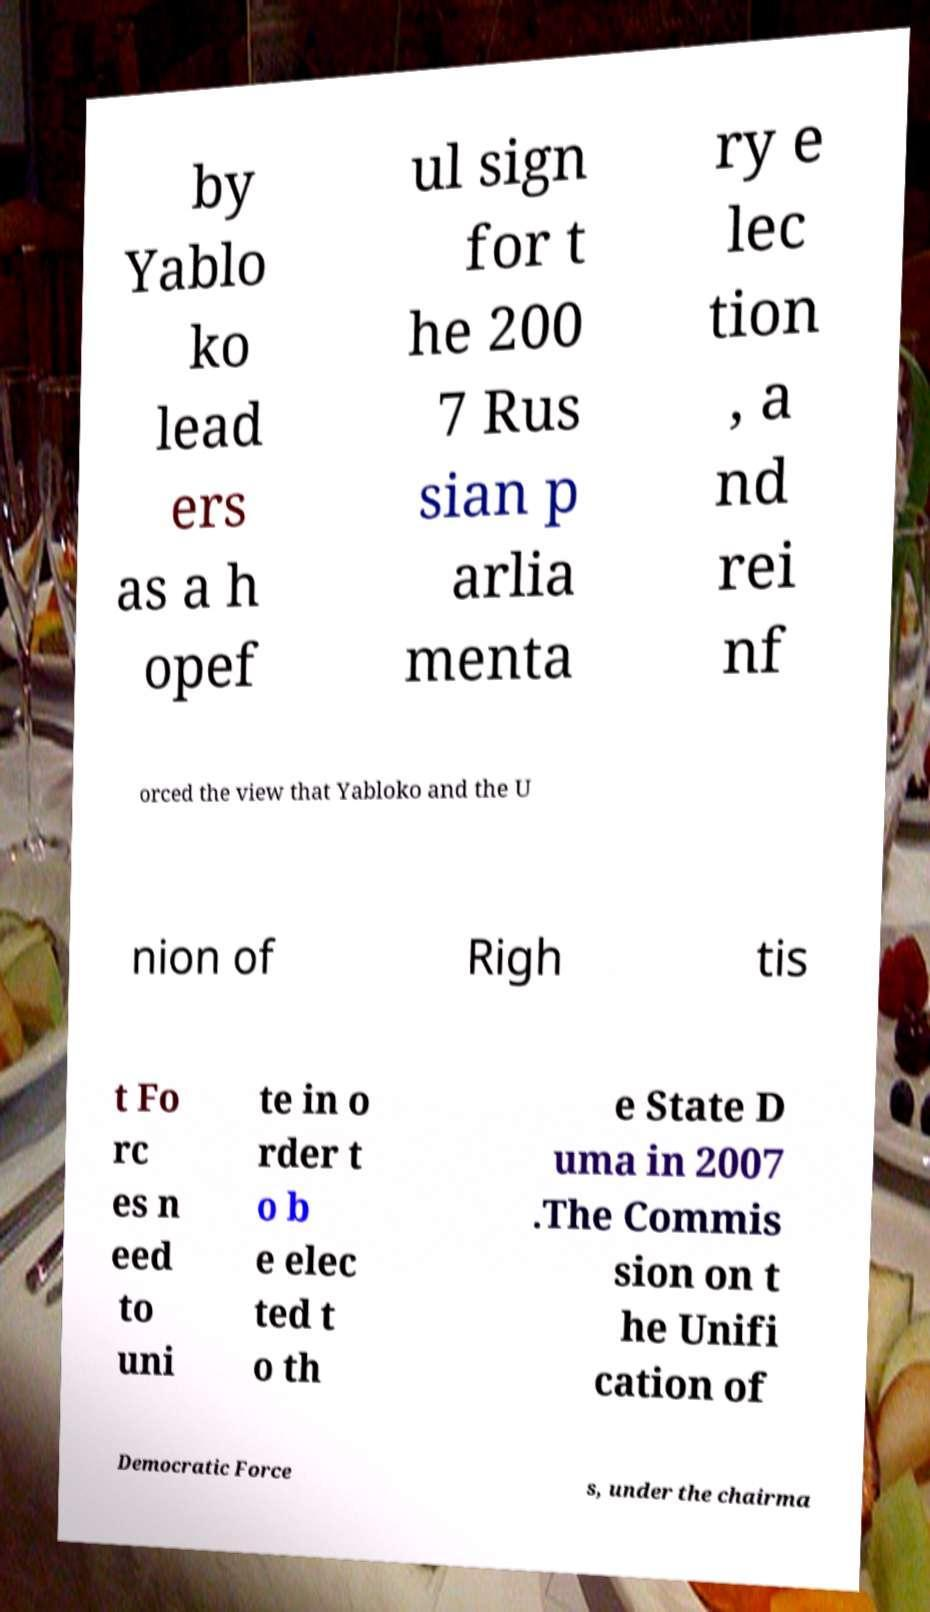Please identify and transcribe the text found in this image. by Yablo ko lead ers as a h opef ul sign for t he 200 7 Rus sian p arlia menta ry e lec tion , a nd rei nf orced the view that Yabloko and the U nion of Righ tis t Fo rc es n eed to uni te in o rder t o b e elec ted t o th e State D uma in 2007 .The Commis sion on t he Unifi cation of Democratic Force s, under the chairma 